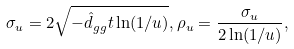Convert formula to latex. <formula><loc_0><loc_0><loc_500><loc_500>\sigma _ { u } = 2 \sqrt { - \hat { d } _ { g g } t \ln ( 1 / u ) } , \rho _ { u } = \frac { \sigma _ { u } } { 2 \ln ( 1 / u ) } ,</formula> 